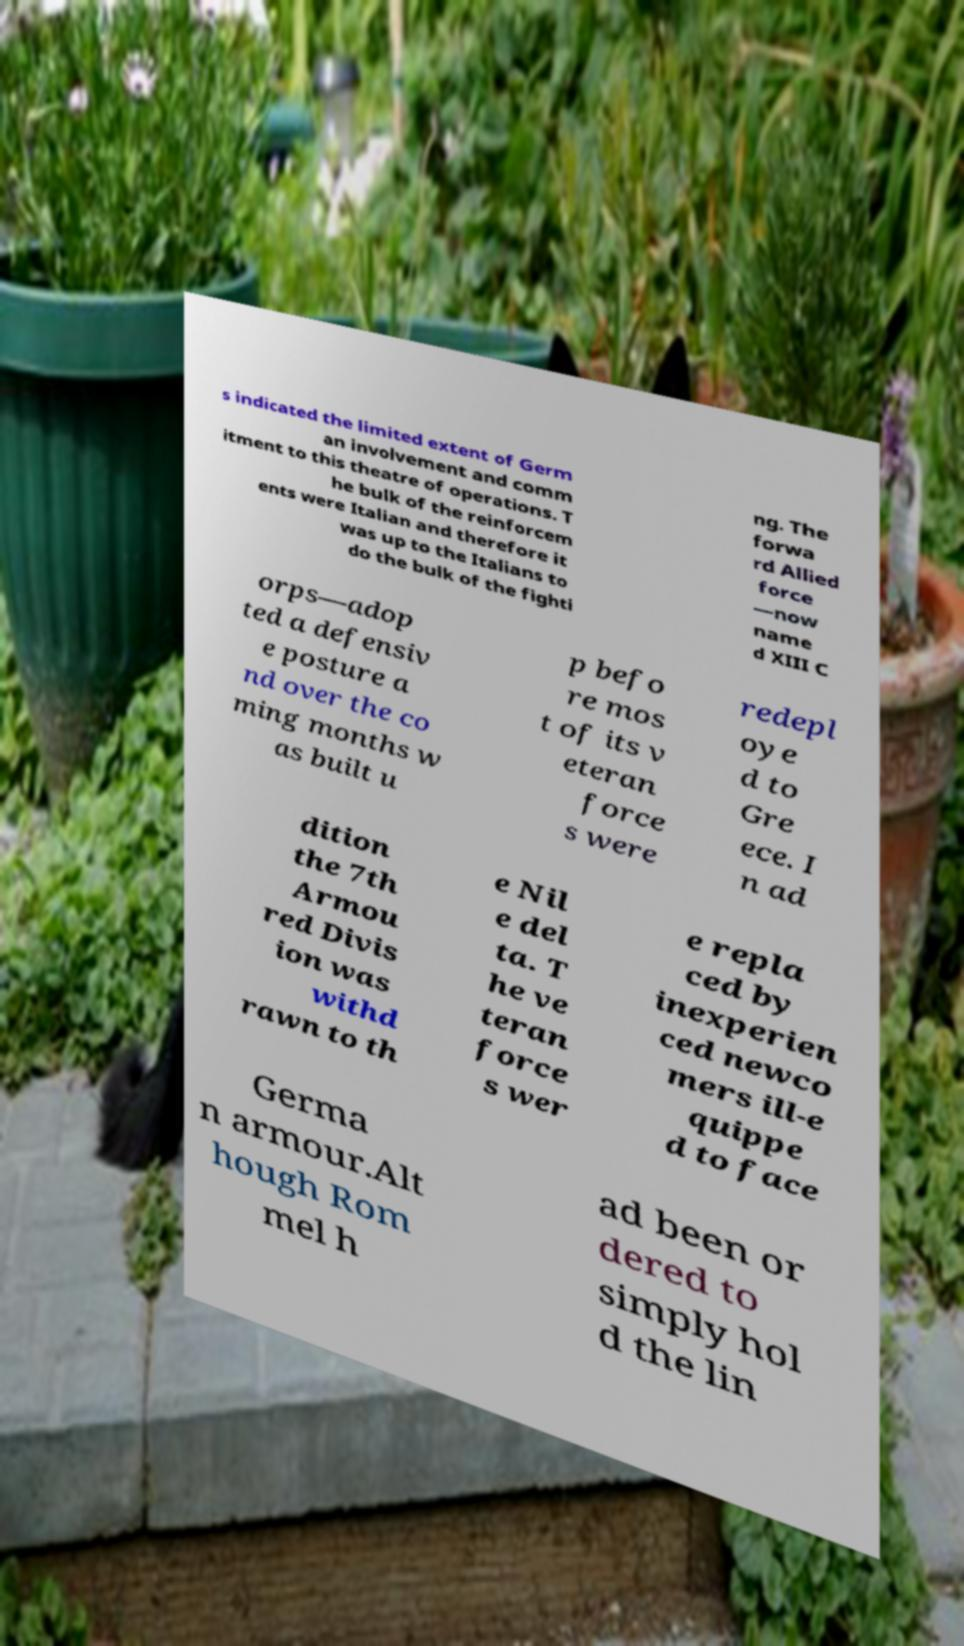For documentation purposes, I need the text within this image transcribed. Could you provide that? s indicated the limited extent of Germ an involvement and comm itment to this theatre of operations. T he bulk of the reinforcem ents were Italian and therefore it was up to the Italians to do the bulk of the fighti ng. The forwa rd Allied force —now name d XIII C orps—adop ted a defensiv e posture a nd over the co ming months w as built u p befo re mos t of its v eteran force s were redepl oye d to Gre ece. I n ad dition the 7th Armou red Divis ion was withd rawn to th e Nil e del ta. T he ve teran force s wer e repla ced by inexperien ced newco mers ill-e quippe d to face Germa n armour.Alt hough Rom mel h ad been or dered to simply hol d the lin 